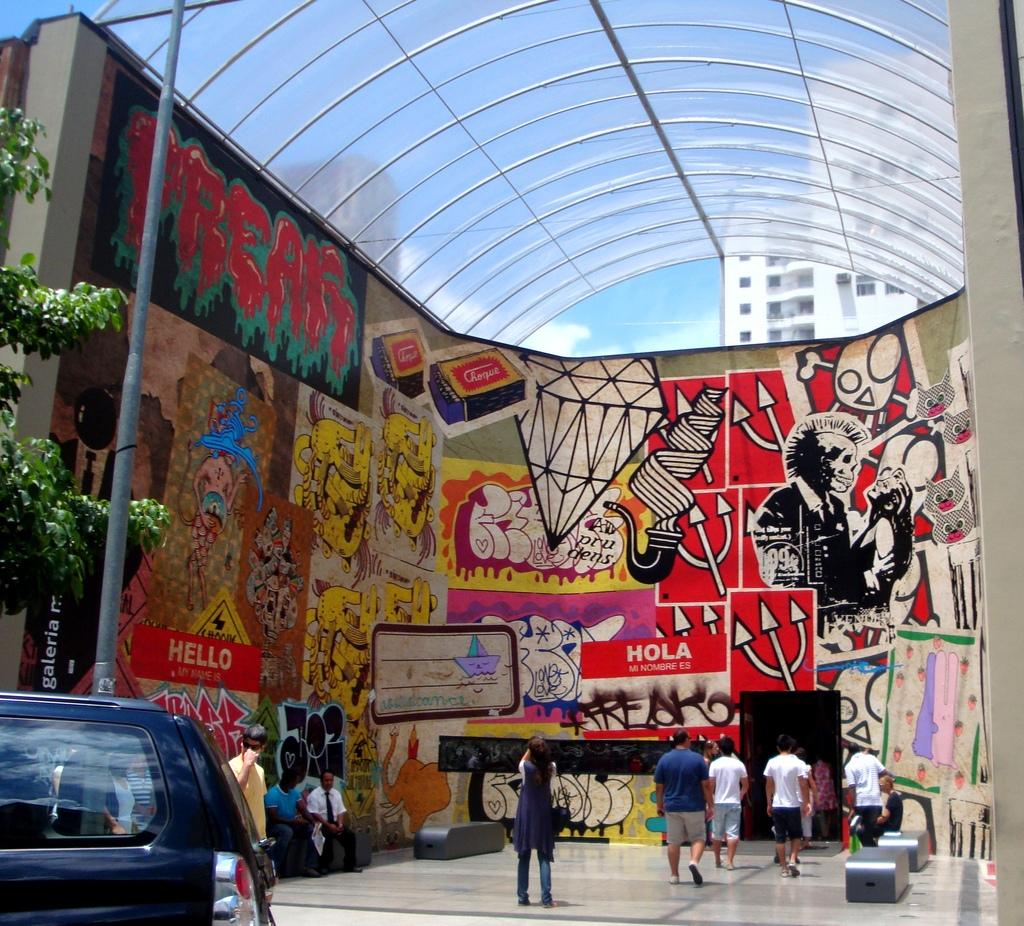<image>
Present a compact description of the photo's key features. A wall filled with art, and sings that say both Hello and Hola 